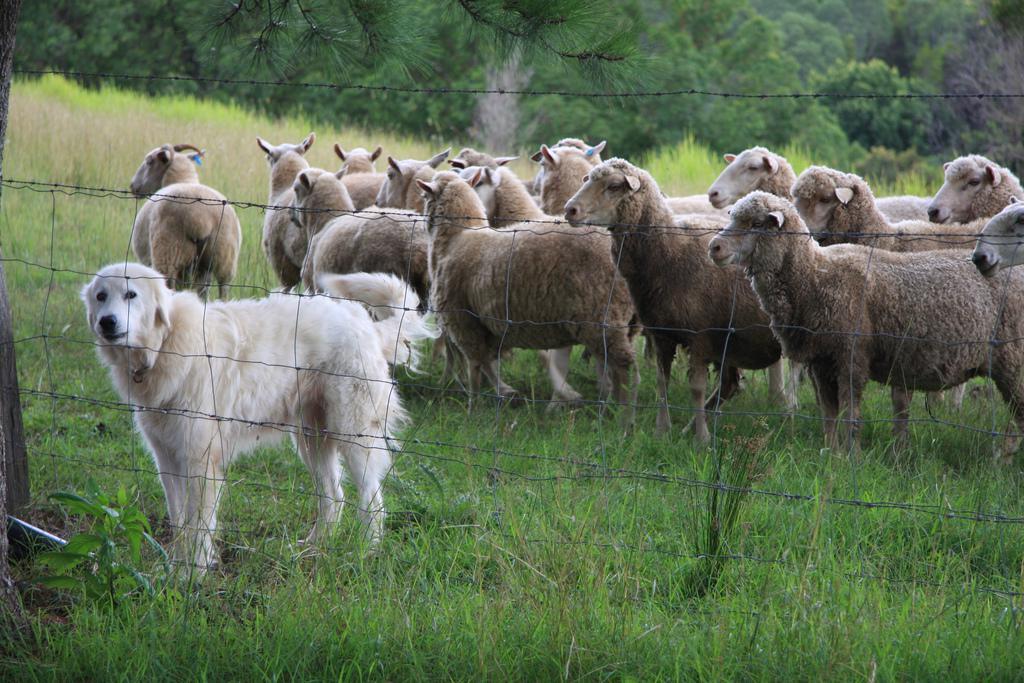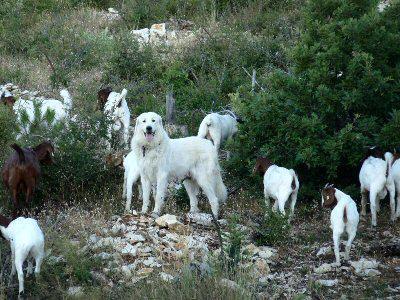The first image is the image on the left, the second image is the image on the right. Examine the images to the left and right. Is the description "An image shows a white dog behind a wire fence with a herd of livestock." accurate? Answer yes or no. Yes. The first image is the image on the left, the second image is the image on the right. For the images shown, is this caption "There is exactly one dog and one goat in the image on the left." true? Answer yes or no. No. The first image is the image on the left, the second image is the image on the right. Evaluate the accuracy of this statement regarding the images: "There is a baby goat on a dog in one of the images.". Is it true? Answer yes or no. No. 